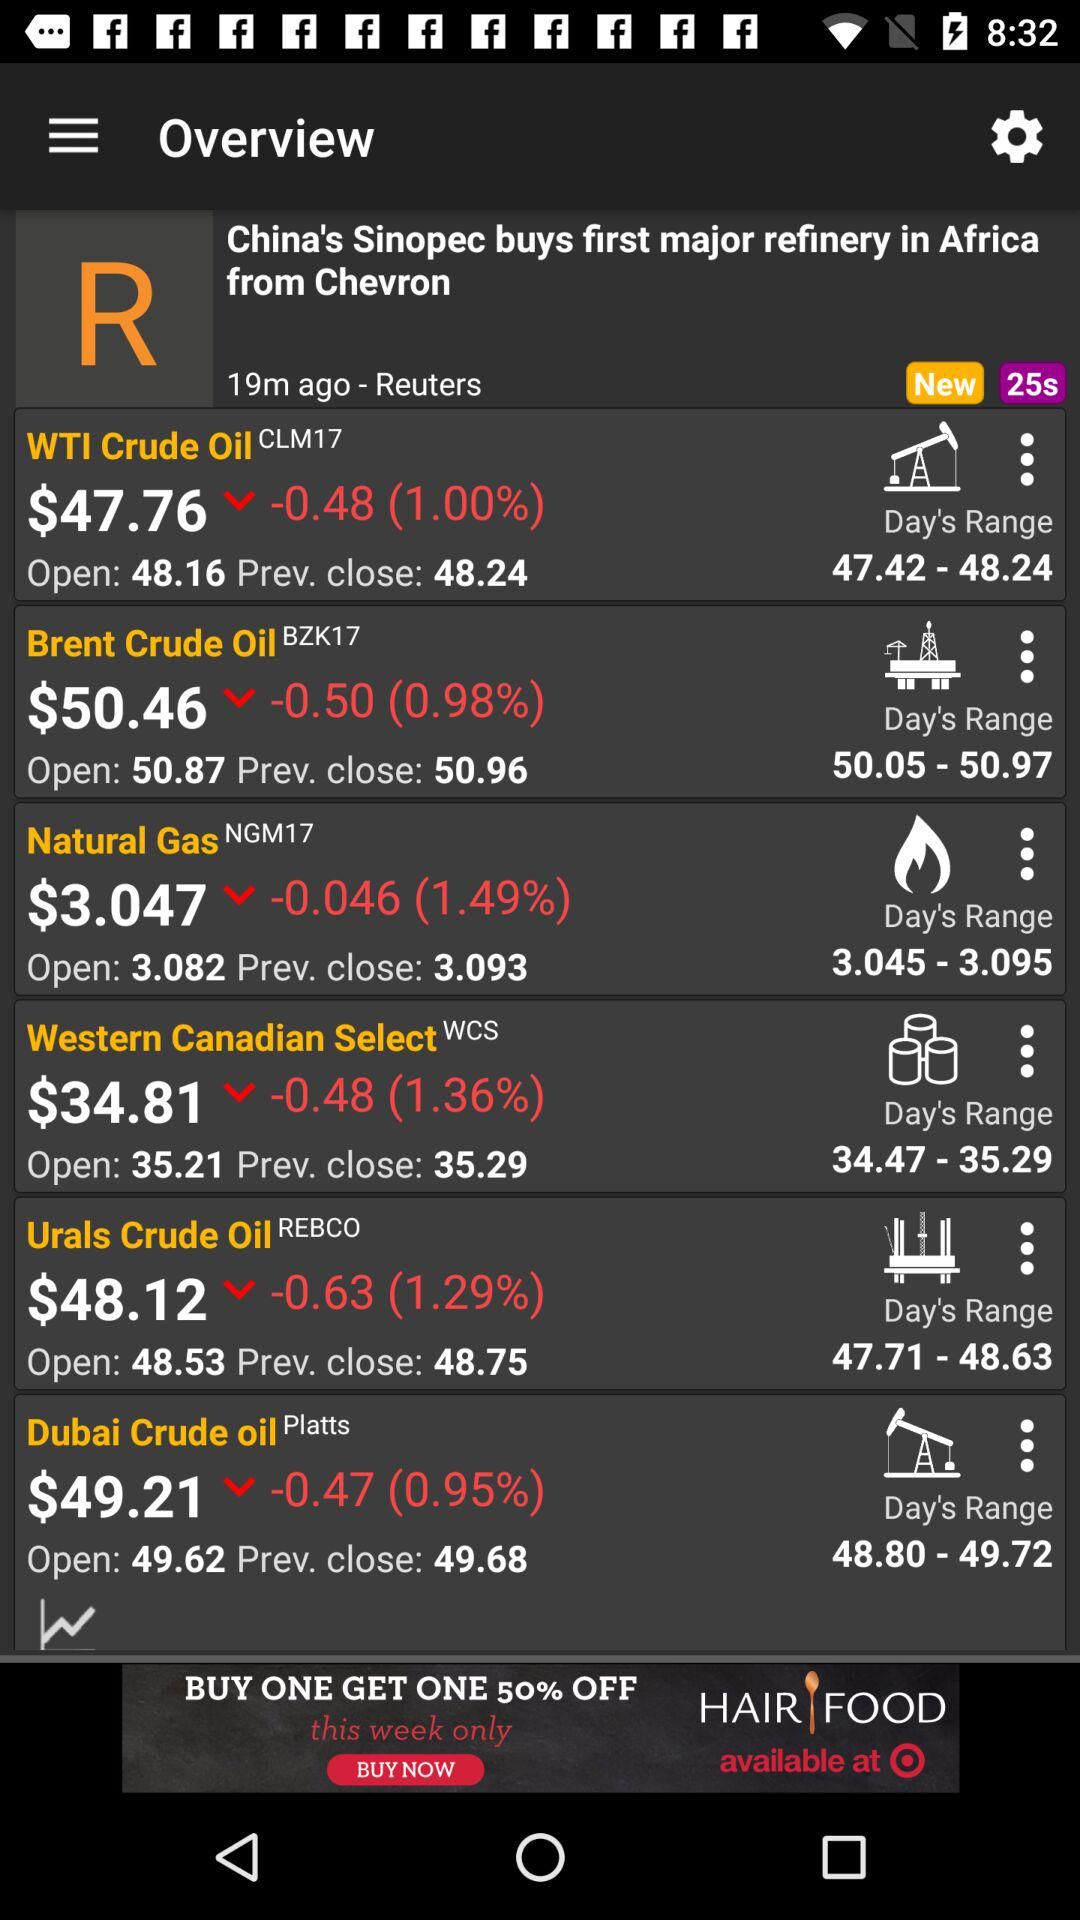What is the open price of Urals Crude Oil? The open price is $48.53. 